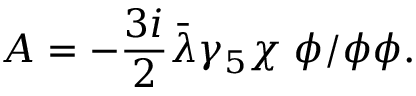<formula> <loc_0><loc_0><loc_500><loc_500>A = - \frac { 3 i } { 2 } { \bar { \lambda } } \gamma _ { 5 } \chi \, \phi / \phi \phi .</formula> 